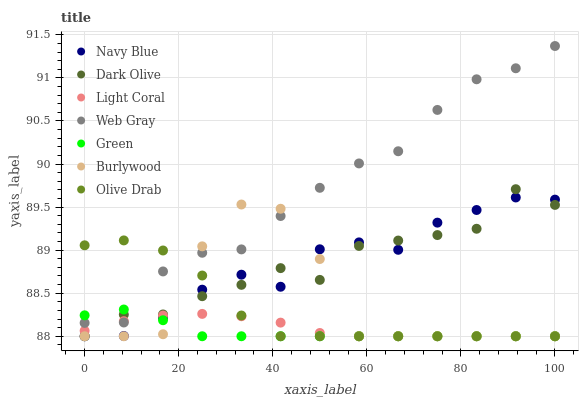Does Green have the minimum area under the curve?
Answer yes or no. Yes. Does Web Gray have the maximum area under the curve?
Answer yes or no. Yes. Does Burlywood have the minimum area under the curve?
Answer yes or no. No. Does Burlywood have the maximum area under the curve?
Answer yes or no. No. Is Light Coral the smoothest?
Answer yes or no. Yes. Is Burlywood the roughest?
Answer yes or no. Yes. Is Navy Blue the smoothest?
Answer yes or no. No. Is Navy Blue the roughest?
Answer yes or no. No. Does Burlywood have the lowest value?
Answer yes or no. Yes. Does Web Gray have the highest value?
Answer yes or no. Yes. Does Burlywood have the highest value?
Answer yes or no. No. Is Navy Blue less than Web Gray?
Answer yes or no. Yes. Is Web Gray greater than Navy Blue?
Answer yes or no. Yes. Does Burlywood intersect Green?
Answer yes or no. Yes. Is Burlywood less than Green?
Answer yes or no. No. Is Burlywood greater than Green?
Answer yes or no. No. Does Navy Blue intersect Web Gray?
Answer yes or no. No. 